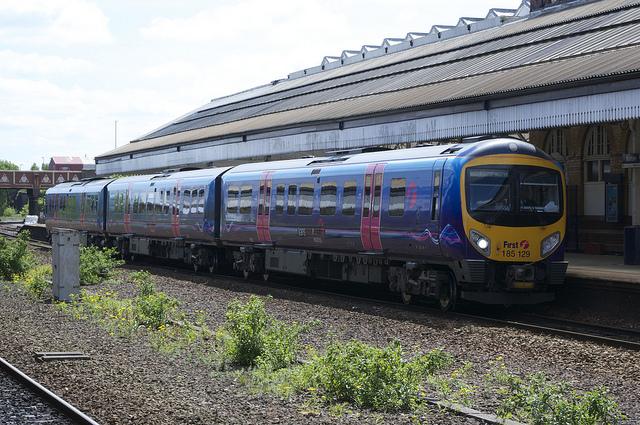Where is the picture taken?
Write a very short answer. Train station. Would it be more than 3 decades ago that this train was modern?
Quick response, please. No. What color are the doors of the train?
Concise answer only. Red. Is this the engine of the train?
Quick response, please. Yes. Is this train modern?
Be succinct. Yes. How many people do you think can fit into this train?
Be succinct. 100. How many feathers?
Write a very short answer. 0. Where is the train going?
Keep it brief. North. What color is the train?
Concise answer only. Blue. Is there any graffiti on the building?
Concise answer only. No. Is this day overcast?
Answer briefly. No. What is the main color of the train?
Be succinct. Blue. 